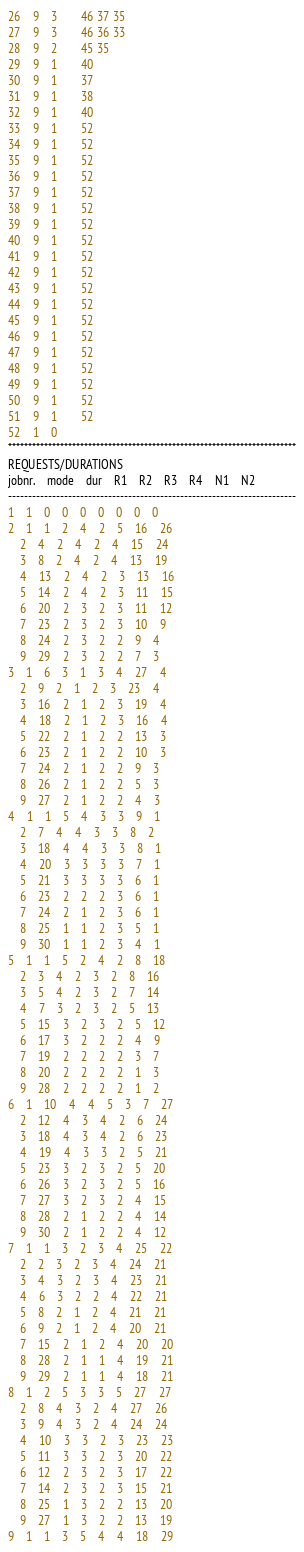Convert code to text. <code><loc_0><loc_0><loc_500><loc_500><_ObjectiveC_>26	9	3		46 37 35 
27	9	3		46 36 33 
28	9	2		45 35 
29	9	1		40 
30	9	1		37 
31	9	1		38 
32	9	1		40 
33	9	1		52 
34	9	1		52 
35	9	1		52 
36	9	1		52 
37	9	1		52 
38	9	1		52 
39	9	1		52 
40	9	1		52 
41	9	1		52 
42	9	1		52 
43	9	1		52 
44	9	1		52 
45	9	1		52 
46	9	1		52 
47	9	1		52 
48	9	1		52 
49	9	1		52 
50	9	1		52 
51	9	1		52 
52	1	0		
************************************************************************
REQUESTS/DURATIONS
jobnr.	mode	dur	R1	R2	R3	R4	N1	N2	
------------------------------------------------------------------------
1	1	0	0	0	0	0	0	0	
2	1	1	2	4	2	5	16	26	
	2	4	2	4	2	4	15	24	
	3	8	2	4	2	4	13	19	
	4	13	2	4	2	3	13	16	
	5	14	2	4	2	3	11	15	
	6	20	2	3	2	3	11	12	
	7	23	2	3	2	3	10	9	
	8	24	2	3	2	2	9	4	
	9	29	2	3	2	2	7	3	
3	1	6	3	1	3	4	27	4	
	2	9	2	1	2	3	23	4	
	3	16	2	1	2	3	19	4	
	4	18	2	1	2	3	16	4	
	5	22	2	1	2	2	13	3	
	6	23	2	1	2	2	10	3	
	7	24	2	1	2	2	9	3	
	8	26	2	1	2	2	5	3	
	9	27	2	1	2	2	4	3	
4	1	1	5	4	3	3	9	1	
	2	7	4	4	3	3	8	2	
	3	18	4	4	3	3	8	1	
	4	20	3	3	3	3	7	1	
	5	21	3	3	3	3	6	1	
	6	23	2	2	2	3	6	1	
	7	24	2	1	2	3	6	1	
	8	25	1	1	2	3	5	1	
	9	30	1	1	2	3	4	1	
5	1	1	5	2	4	2	8	18	
	2	3	4	2	3	2	8	16	
	3	5	4	2	3	2	7	14	
	4	7	3	2	3	2	5	13	
	5	15	3	2	3	2	5	12	
	6	17	3	2	2	2	4	9	
	7	19	2	2	2	2	3	7	
	8	20	2	2	2	2	1	3	
	9	28	2	2	2	2	1	2	
6	1	10	4	4	5	3	7	27	
	2	12	4	3	4	2	6	24	
	3	18	4	3	4	2	6	23	
	4	19	4	3	3	2	5	21	
	5	23	3	2	3	2	5	20	
	6	26	3	2	3	2	5	16	
	7	27	3	2	3	2	4	15	
	8	28	2	1	2	2	4	14	
	9	30	2	1	2	2	4	12	
7	1	1	3	2	3	4	25	22	
	2	2	3	2	3	4	24	21	
	3	4	3	2	3	4	23	21	
	4	6	3	2	2	4	22	21	
	5	8	2	1	2	4	21	21	
	6	9	2	1	2	4	20	21	
	7	15	2	1	2	4	20	20	
	8	28	2	1	1	4	19	21	
	9	29	2	1	1	4	18	21	
8	1	2	5	3	3	5	27	27	
	2	8	4	3	2	4	27	26	
	3	9	4	3	2	4	24	24	
	4	10	3	3	2	3	23	23	
	5	11	3	3	2	3	20	22	
	6	12	2	3	2	3	17	22	
	7	14	2	3	2	3	15	21	
	8	25	1	3	2	2	13	20	
	9	27	1	3	2	2	13	19	
9	1	1	3	5	4	4	18	29	</code> 